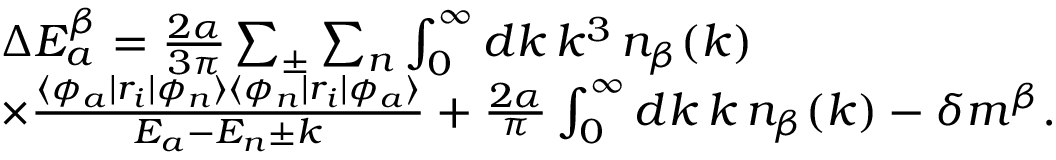Convert formula to latex. <formula><loc_0><loc_0><loc_500><loc_500>\begin{array} { r l } & { \quad \Delta E _ { a } ^ { \beta } = \frac { 2 \alpha } { 3 \pi } \sum _ { \pm } \sum _ { n } \int _ { 0 } ^ { \infty } d k \, k ^ { 3 } \, n _ { \beta } ( k ) } \\ & { \quad \times \frac { \langle \phi _ { a } | r _ { i } | \phi _ { n } \rangle \langle \phi _ { n } | r _ { i } | \phi _ { a } \rangle } { E _ { a } - E _ { n } \pm k } + \frac { 2 \alpha } { \pi } \int _ { 0 } ^ { \infty } d k \, k \, n _ { \beta } ( k ) - \delta m ^ { \beta } . } \end{array}</formula> 